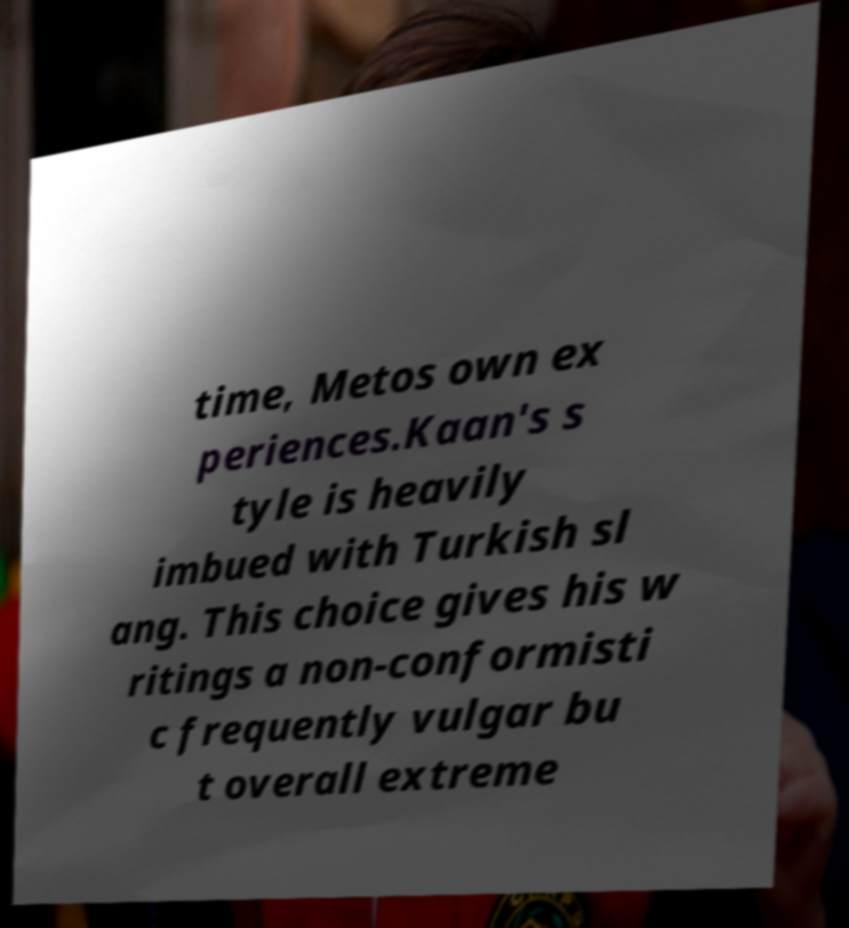Can you accurately transcribe the text from the provided image for me? time, Metos own ex periences.Kaan's s tyle is heavily imbued with Turkish sl ang. This choice gives his w ritings a non-conformisti c frequently vulgar bu t overall extreme 